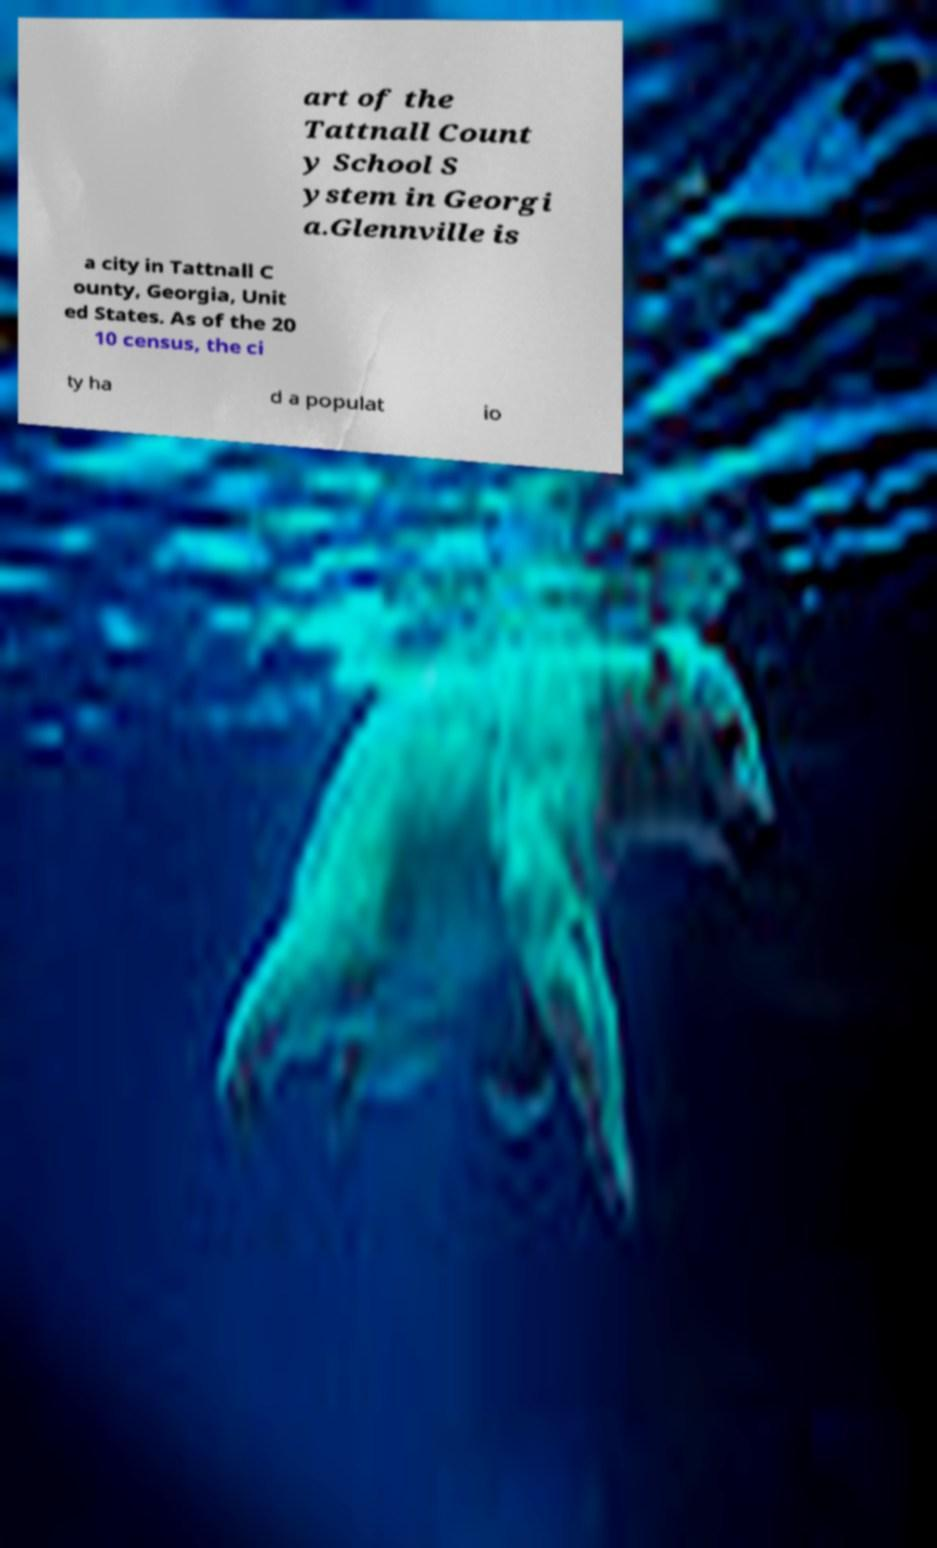Can you accurately transcribe the text from the provided image for me? art of the Tattnall Count y School S ystem in Georgi a.Glennville is a city in Tattnall C ounty, Georgia, Unit ed States. As of the 20 10 census, the ci ty ha d a populat io 